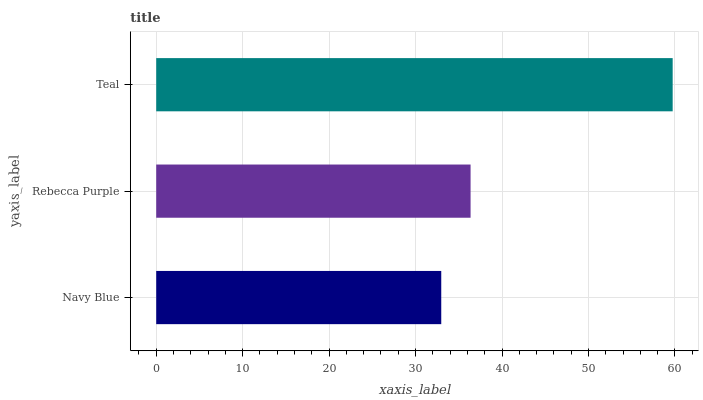Is Navy Blue the minimum?
Answer yes or no. Yes. Is Teal the maximum?
Answer yes or no. Yes. Is Rebecca Purple the minimum?
Answer yes or no. No. Is Rebecca Purple the maximum?
Answer yes or no. No. Is Rebecca Purple greater than Navy Blue?
Answer yes or no. Yes. Is Navy Blue less than Rebecca Purple?
Answer yes or no. Yes. Is Navy Blue greater than Rebecca Purple?
Answer yes or no. No. Is Rebecca Purple less than Navy Blue?
Answer yes or no. No. Is Rebecca Purple the high median?
Answer yes or no. Yes. Is Rebecca Purple the low median?
Answer yes or no. Yes. Is Teal the high median?
Answer yes or no. No. Is Navy Blue the low median?
Answer yes or no. No. 